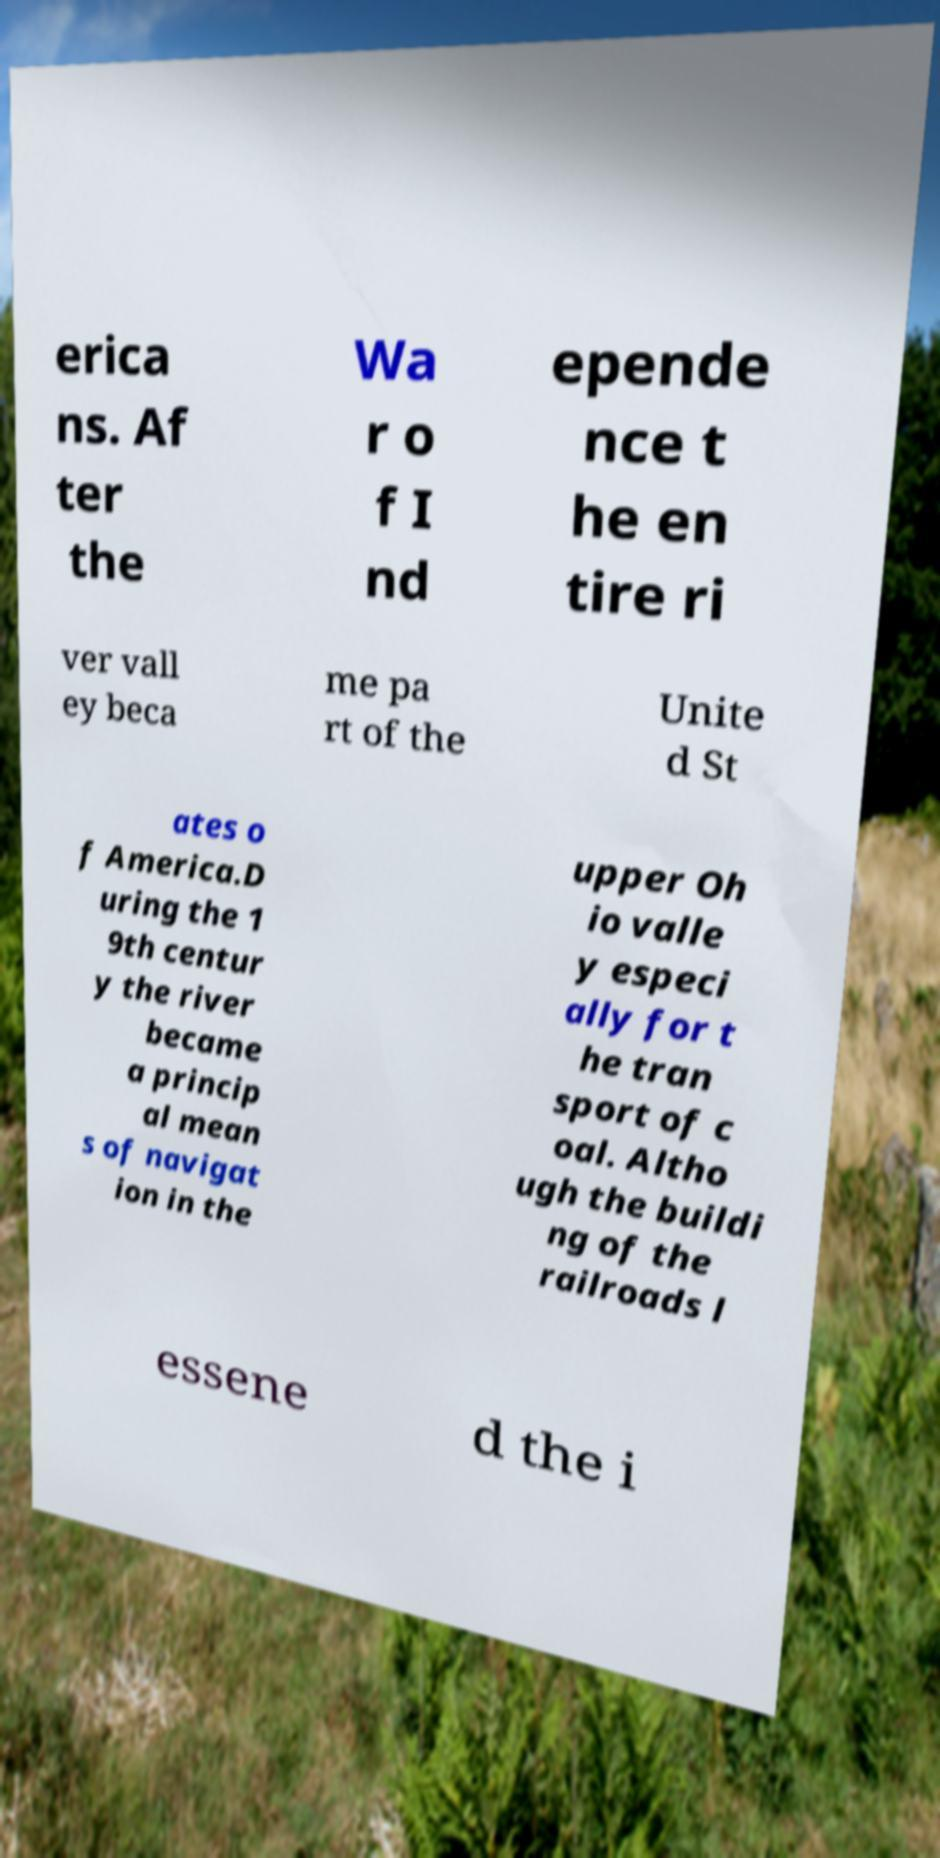What messages or text are displayed in this image? I need them in a readable, typed format. erica ns. Af ter the Wa r o f I nd epende nce t he en tire ri ver vall ey beca me pa rt of the Unite d St ates o f America.D uring the 1 9th centur y the river became a princip al mean s of navigat ion in the upper Oh io valle y especi ally for t he tran sport of c oal. Altho ugh the buildi ng of the railroads l essene d the i 